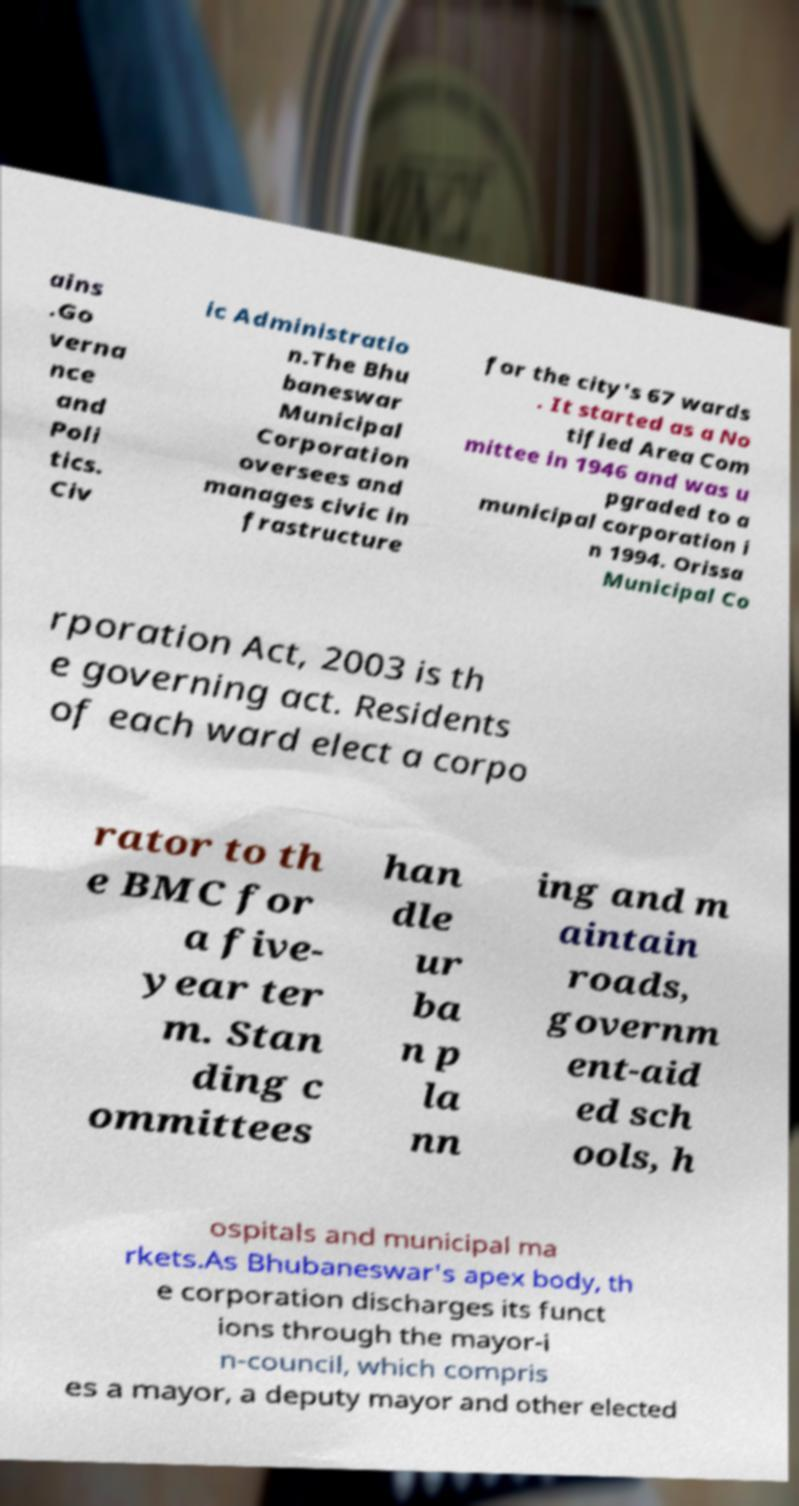Could you assist in decoding the text presented in this image and type it out clearly? ains .Go verna nce and Poli tics. Civ ic Administratio n.The Bhu baneswar Municipal Corporation oversees and manages civic in frastructure for the city's 67 wards . It started as a No tified Area Com mittee in 1946 and was u pgraded to a municipal corporation i n 1994. Orissa Municipal Co rporation Act, 2003 is th e governing act. Residents of each ward elect a corpo rator to th e BMC for a five- year ter m. Stan ding c ommittees han dle ur ba n p la nn ing and m aintain roads, governm ent-aid ed sch ools, h ospitals and municipal ma rkets.As Bhubaneswar's apex body, th e corporation discharges its funct ions through the mayor-i n-council, which compris es a mayor, a deputy mayor and other elected 